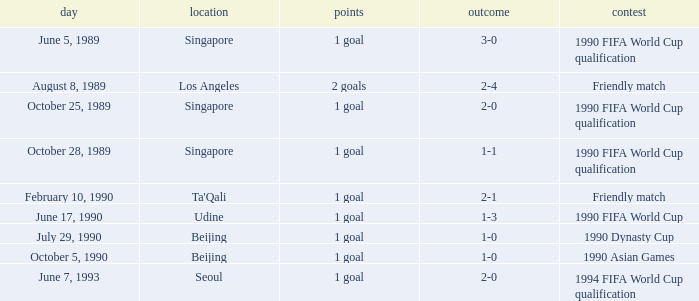What was the score of the match with a 3-0 result? 1 goal. 